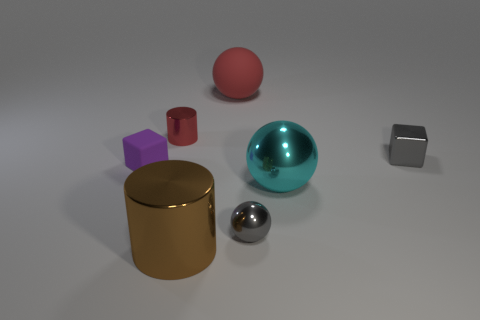Add 2 large rubber things. How many objects exist? 9 Subtract all blocks. How many objects are left? 5 Add 6 big cyan objects. How many big cyan objects exist? 7 Subtract 1 red spheres. How many objects are left? 6 Subtract all gray metal blocks. Subtract all purple matte cubes. How many objects are left? 5 Add 7 big cylinders. How many big cylinders are left? 8 